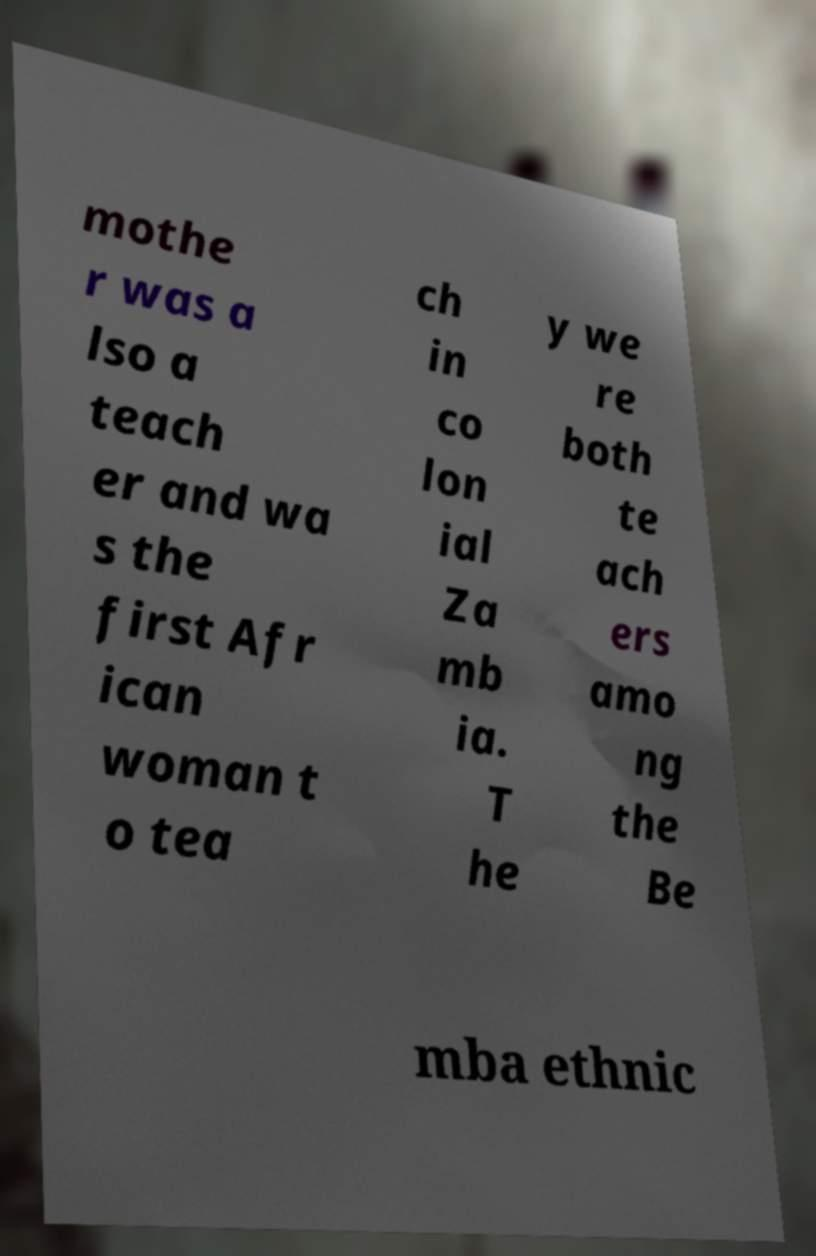I need the written content from this picture converted into text. Can you do that? mothe r was a lso a teach er and wa s the first Afr ican woman t o tea ch in co lon ial Za mb ia. T he y we re both te ach ers amo ng the Be mba ethnic 